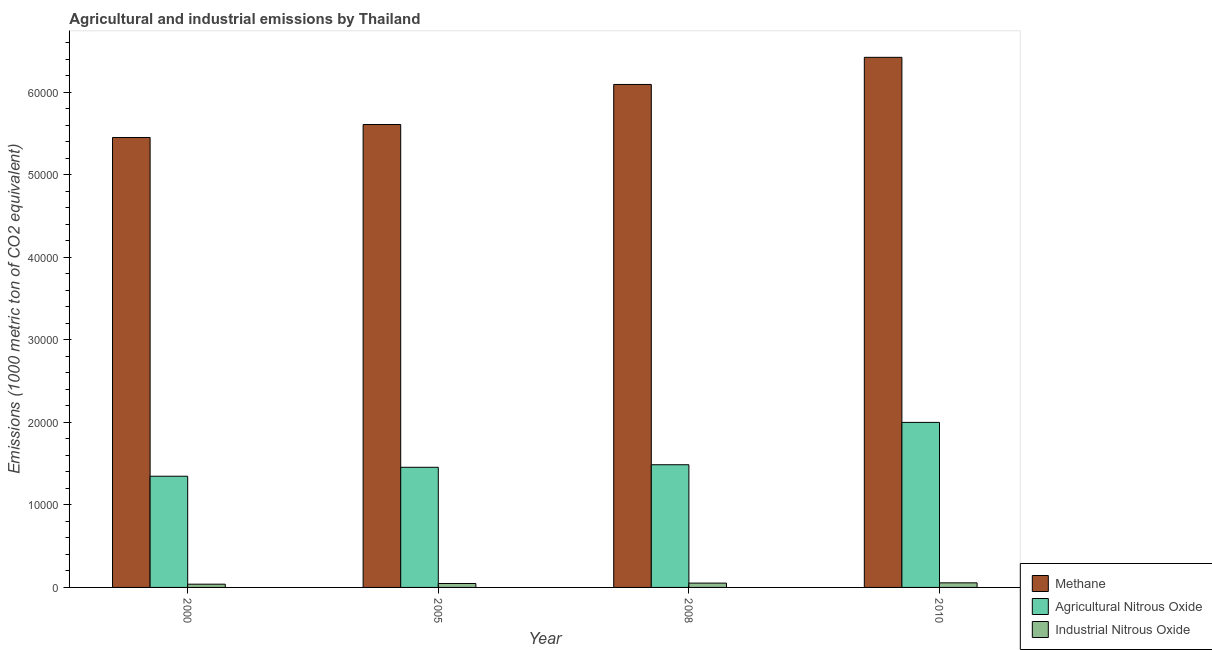Are the number of bars per tick equal to the number of legend labels?
Provide a short and direct response. Yes. Are the number of bars on each tick of the X-axis equal?
Provide a short and direct response. Yes. How many bars are there on the 2nd tick from the left?
Give a very brief answer. 3. In how many cases, is the number of bars for a given year not equal to the number of legend labels?
Provide a short and direct response. 0. What is the amount of industrial nitrous oxide emissions in 2005?
Make the answer very short. 477.4. Across all years, what is the maximum amount of agricultural nitrous oxide emissions?
Your answer should be compact. 2.00e+04. Across all years, what is the minimum amount of agricultural nitrous oxide emissions?
Offer a very short reply. 1.35e+04. What is the total amount of methane emissions in the graph?
Give a very brief answer. 2.36e+05. What is the difference between the amount of industrial nitrous oxide emissions in 2005 and that in 2010?
Keep it short and to the point. -77.2. What is the difference between the amount of methane emissions in 2008 and the amount of agricultural nitrous oxide emissions in 2005?
Offer a very short reply. 4853.3. What is the average amount of methane emissions per year?
Offer a very short reply. 5.90e+04. In the year 2005, what is the difference between the amount of industrial nitrous oxide emissions and amount of methane emissions?
Keep it short and to the point. 0. In how many years, is the amount of methane emissions greater than 36000 metric ton?
Ensure brevity in your answer.  4. What is the ratio of the amount of agricultural nitrous oxide emissions in 2005 to that in 2010?
Offer a terse response. 0.73. Is the amount of industrial nitrous oxide emissions in 2005 less than that in 2008?
Provide a succinct answer. Yes. What is the difference between the highest and the second highest amount of methane emissions?
Your response must be concise. 3287.7. What is the difference between the highest and the lowest amount of industrial nitrous oxide emissions?
Offer a very short reply. 161.2. In how many years, is the amount of agricultural nitrous oxide emissions greater than the average amount of agricultural nitrous oxide emissions taken over all years?
Your answer should be compact. 1. What does the 3rd bar from the left in 2000 represents?
Ensure brevity in your answer.  Industrial Nitrous Oxide. What does the 3rd bar from the right in 2010 represents?
Keep it short and to the point. Methane. Is it the case that in every year, the sum of the amount of methane emissions and amount of agricultural nitrous oxide emissions is greater than the amount of industrial nitrous oxide emissions?
Offer a very short reply. Yes. Are all the bars in the graph horizontal?
Keep it short and to the point. No. How many years are there in the graph?
Ensure brevity in your answer.  4. What is the difference between two consecutive major ticks on the Y-axis?
Provide a short and direct response. 10000. Are the values on the major ticks of Y-axis written in scientific E-notation?
Keep it short and to the point. No. Does the graph contain any zero values?
Keep it short and to the point. No. How many legend labels are there?
Keep it short and to the point. 3. How are the legend labels stacked?
Make the answer very short. Vertical. What is the title of the graph?
Your answer should be very brief. Agricultural and industrial emissions by Thailand. Does "Food" appear as one of the legend labels in the graph?
Your answer should be very brief. No. What is the label or title of the X-axis?
Your response must be concise. Year. What is the label or title of the Y-axis?
Provide a succinct answer. Emissions (1000 metric ton of CO2 equivalent). What is the Emissions (1000 metric ton of CO2 equivalent) of Methane in 2000?
Keep it short and to the point. 5.45e+04. What is the Emissions (1000 metric ton of CO2 equivalent) in Agricultural Nitrous Oxide in 2000?
Keep it short and to the point. 1.35e+04. What is the Emissions (1000 metric ton of CO2 equivalent) of Industrial Nitrous Oxide in 2000?
Your answer should be very brief. 393.4. What is the Emissions (1000 metric ton of CO2 equivalent) of Methane in 2005?
Offer a terse response. 5.61e+04. What is the Emissions (1000 metric ton of CO2 equivalent) in Agricultural Nitrous Oxide in 2005?
Keep it short and to the point. 1.46e+04. What is the Emissions (1000 metric ton of CO2 equivalent) in Industrial Nitrous Oxide in 2005?
Offer a very short reply. 477.4. What is the Emissions (1000 metric ton of CO2 equivalent) of Methane in 2008?
Provide a short and direct response. 6.10e+04. What is the Emissions (1000 metric ton of CO2 equivalent) of Agricultural Nitrous Oxide in 2008?
Keep it short and to the point. 1.49e+04. What is the Emissions (1000 metric ton of CO2 equivalent) of Industrial Nitrous Oxide in 2008?
Your answer should be compact. 524. What is the Emissions (1000 metric ton of CO2 equivalent) of Methane in 2010?
Offer a terse response. 6.42e+04. What is the Emissions (1000 metric ton of CO2 equivalent) in Agricultural Nitrous Oxide in 2010?
Offer a very short reply. 2.00e+04. What is the Emissions (1000 metric ton of CO2 equivalent) of Industrial Nitrous Oxide in 2010?
Your answer should be compact. 554.6. Across all years, what is the maximum Emissions (1000 metric ton of CO2 equivalent) of Methane?
Ensure brevity in your answer.  6.42e+04. Across all years, what is the maximum Emissions (1000 metric ton of CO2 equivalent) of Agricultural Nitrous Oxide?
Your response must be concise. 2.00e+04. Across all years, what is the maximum Emissions (1000 metric ton of CO2 equivalent) in Industrial Nitrous Oxide?
Your answer should be very brief. 554.6. Across all years, what is the minimum Emissions (1000 metric ton of CO2 equivalent) in Methane?
Offer a terse response. 5.45e+04. Across all years, what is the minimum Emissions (1000 metric ton of CO2 equivalent) in Agricultural Nitrous Oxide?
Provide a short and direct response. 1.35e+04. Across all years, what is the minimum Emissions (1000 metric ton of CO2 equivalent) in Industrial Nitrous Oxide?
Offer a very short reply. 393.4. What is the total Emissions (1000 metric ton of CO2 equivalent) of Methane in the graph?
Your answer should be compact. 2.36e+05. What is the total Emissions (1000 metric ton of CO2 equivalent) of Agricultural Nitrous Oxide in the graph?
Keep it short and to the point. 6.29e+04. What is the total Emissions (1000 metric ton of CO2 equivalent) of Industrial Nitrous Oxide in the graph?
Make the answer very short. 1949.4. What is the difference between the Emissions (1000 metric ton of CO2 equivalent) of Methane in 2000 and that in 2005?
Your answer should be very brief. -1573.2. What is the difference between the Emissions (1000 metric ton of CO2 equivalent) in Agricultural Nitrous Oxide in 2000 and that in 2005?
Make the answer very short. -1081.7. What is the difference between the Emissions (1000 metric ton of CO2 equivalent) of Industrial Nitrous Oxide in 2000 and that in 2005?
Keep it short and to the point. -84. What is the difference between the Emissions (1000 metric ton of CO2 equivalent) of Methane in 2000 and that in 2008?
Provide a short and direct response. -6426.5. What is the difference between the Emissions (1000 metric ton of CO2 equivalent) of Agricultural Nitrous Oxide in 2000 and that in 2008?
Ensure brevity in your answer.  -1391. What is the difference between the Emissions (1000 metric ton of CO2 equivalent) of Industrial Nitrous Oxide in 2000 and that in 2008?
Give a very brief answer. -130.6. What is the difference between the Emissions (1000 metric ton of CO2 equivalent) in Methane in 2000 and that in 2010?
Provide a short and direct response. -9714.2. What is the difference between the Emissions (1000 metric ton of CO2 equivalent) in Agricultural Nitrous Oxide in 2000 and that in 2010?
Give a very brief answer. -6523.1. What is the difference between the Emissions (1000 metric ton of CO2 equivalent) in Industrial Nitrous Oxide in 2000 and that in 2010?
Keep it short and to the point. -161.2. What is the difference between the Emissions (1000 metric ton of CO2 equivalent) of Methane in 2005 and that in 2008?
Offer a very short reply. -4853.3. What is the difference between the Emissions (1000 metric ton of CO2 equivalent) of Agricultural Nitrous Oxide in 2005 and that in 2008?
Make the answer very short. -309.3. What is the difference between the Emissions (1000 metric ton of CO2 equivalent) in Industrial Nitrous Oxide in 2005 and that in 2008?
Keep it short and to the point. -46.6. What is the difference between the Emissions (1000 metric ton of CO2 equivalent) of Methane in 2005 and that in 2010?
Make the answer very short. -8141. What is the difference between the Emissions (1000 metric ton of CO2 equivalent) of Agricultural Nitrous Oxide in 2005 and that in 2010?
Provide a succinct answer. -5441.4. What is the difference between the Emissions (1000 metric ton of CO2 equivalent) in Industrial Nitrous Oxide in 2005 and that in 2010?
Ensure brevity in your answer.  -77.2. What is the difference between the Emissions (1000 metric ton of CO2 equivalent) in Methane in 2008 and that in 2010?
Your answer should be very brief. -3287.7. What is the difference between the Emissions (1000 metric ton of CO2 equivalent) in Agricultural Nitrous Oxide in 2008 and that in 2010?
Your answer should be compact. -5132.1. What is the difference between the Emissions (1000 metric ton of CO2 equivalent) of Industrial Nitrous Oxide in 2008 and that in 2010?
Make the answer very short. -30.6. What is the difference between the Emissions (1000 metric ton of CO2 equivalent) of Methane in 2000 and the Emissions (1000 metric ton of CO2 equivalent) of Agricultural Nitrous Oxide in 2005?
Your response must be concise. 4.00e+04. What is the difference between the Emissions (1000 metric ton of CO2 equivalent) of Methane in 2000 and the Emissions (1000 metric ton of CO2 equivalent) of Industrial Nitrous Oxide in 2005?
Offer a terse response. 5.40e+04. What is the difference between the Emissions (1000 metric ton of CO2 equivalent) of Agricultural Nitrous Oxide in 2000 and the Emissions (1000 metric ton of CO2 equivalent) of Industrial Nitrous Oxide in 2005?
Provide a succinct answer. 1.30e+04. What is the difference between the Emissions (1000 metric ton of CO2 equivalent) of Methane in 2000 and the Emissions (1000 metric ton of CO2 equivalent) of Agricultural Nitrous Oxide in 2008?
Offer a very short reply. 3.97e+04. What is the difference between the Emissions (1000 metric ton of CO2 equivalent) of Methane in 2000 and the Emissions (1000 metric ton of CO2 equivalent) of Industrial Nitrous Oxide in 2008?
Your response must be concise. 5.40e+04. What is the difference between the Emissions (1000 metric ton of CO2 equivalent) in Agricultural Nitrous Oxide in 2000 and the Emissions (1000 metric ton of CO2 equivalent) in Industrial Nitrous Oxide in 2008?
Give a very brief answer. 1.30e+04. What is the difference between the Emissions (1000 metric ton of CO2 equivalent) of Methane in 2000 and the Emissions (1000 metric ton of CO2 equivalent) of Agricultural Nitrous Oxide in 2010?
Your response must be concise. 3.45e+04. What is the difference between the Emissions (1000 metric ton of CO2 equivalent) of Methane in 2000 and the Emissions (1000 metric ton of CO2 equivalent) of Industrial Nitrous Oxide in 2010?
Your answer should be compact. 5.40e+04. What is the difference between the Emissions (1000 metric ton of CO2 equivalent) in Agricultural Nitrous Oxide in 2000 and the Emissions (1000 metric ton of CO2 equivalent) in Industrial Nitrous Oxide in 2010?
Provide a short and direct response. 1.29e+04. What is the difference between the Emissions (1000 metric ton of CO2 equivalent) of Methane in 2005 and the Emissions (1000 metric ton of CO2 equivalent) of Agricultural Nitrous Oxide in 2008?
Give a very brief answer. 4.12e+04. What is the difference between the Emissions (1000 metric ton of CO2 equivalent) of Methane in 2005 and the Emissions (1000 metric ton of CO2 equivalent) of Industrial Nitrous Oxide in 2008?
Give a very brief answer. 5.56e+04. What is the difference between the Emissions (1000 metric ton of CO2 equivalent) in Agricultural Nitrous Oxide in 2005 and the Emissions (1000 metric ton of CO2 equivalent) in Industrial Nitrous Oxide in 2008?
Ensure brevity in your answer.  1.40e+04. What is the difference between the Emissions (1000 metric ton of CO2 equivalent) of Methane in 2005 and the Emissions (1000 metric ton of CO2 equivalent) of Agricultural Nitrous Oxide in 2010?
Ensure brevity in your answer.  3.61e+04. What is the difference between the Emissions (1000 metric ton of CO2 equivalent) of Methane in 2005 and the Emissions (1000 metric ton of CO2 equivalent) of Industrial Nitrous Oxide in 2010?
Give a very brief answer. 5.55e+04. What is the difference between the Emissions (1000 metric ton of CO2 equivalent) of Agricultural Nitrous Oxide in 2005 and the Emissions (1000 metric ton of CO2 equivalent) of Industrial Nitrous Oxide in 2010?
Offer a terse response. 1.40e+04. What is the difference between the Emissions (1000 metric ton of CO2 equivalent) in Methane in 2008 and the Emissions (1000 metric ton of CO2 equivalent) in Agricultural Nitrous Oxide in 2010?
Keep it short and to the point. 4.10e+04. What is the difference between the Emissions (1000 metric ton of CO2 equivalent) in Methane in 2008 and the Emissions (1000 metric ton of CO2 equivalent) in Industrial Nitrous Oxide in 2010?
Keep it short and to the point. 6.04e+04. What is the difference between the Emissions (1000 metric ton of CO2 equivalent) of Agricultural Nitrous Oxide in 2008 and the Emissions (1000 metric ton of CO2 equivalent) of Industrial Nitrous Oxide in 2010?
Give a very brief answer. 1.43e+04. What is the average Emissions (1000 metric ton of CO2 equivalent) in Methane per year?
Your answer should be very brief. 5.90e+04. What is the average Emissions (1000 metric ton of CO2 equivalent) in Agricultural Nitrous Oxide per year?
Your answer should be very brief. 1.57e+04. What is the average Emissions (1000 metric ton of CO2 equivalent) in Industrial Nitrous Oxide per year?
Your response must be concise. 487.35. In the year 2000, what is the difference between the Emissions (1000 metric ton of CO2 equivalent) in Methane and Emissions (1000 metric ton of CO2 equivalent) in Agricultural Nitrous Oxide?
Your response must be concise. 4.10e+04. In the year 2000, what is the difference between the Emissions (1000 metric ton of CO2 equivalent) in Methane and Emissions (1000 metric ton of CO2 equivalent) in Industrial Nitrous Oxide?
Make the answer very short. 5.41e+04. In the year 2000, what is the difference between the Emissions (1000 metric ton of CO2 equivalent) of Agricultural Nitrous Oxide and Emissions (1000 metric ton of CO2 equivalent) of Industrial Nitrous Oxide?
Make the answer very short. 1.31e+04. In the year 2005, what is the difference between the Emissions (1000 metric ton of CO2 equivalent) of Methane and Emissions (1000 metric ton of CO2 equivalent) of Agricultural Nitrous Oxide?
Your response must be concise. 4.15e+04. In the year 2005, what is the difference between the Emissions (1000 metric ton of CO2 equivalent) in Methane and Emissions (1000 metric ton of CO2 equivalent) in Industrial Nitrous Oxide?
Offer a terse response. 5.56e+04. In the year 2005, what is the difference between the Emissions (1000 metric ton of CO2 equivalent) of Agricultural Nitrous Oxide and Emissions (1000 metric ton of CO2 equivalent) of Industrial Nitrous Oxide?
Your response must be concise. 1.41e+04. In the year 2008, what is the difference between the Emissions (1000 metric ton of CO2 equivalent) of Methane and Emissions (1000 metric ton of CO2 equivalent) of Agricultural Nitrous Oxide?
Keep it short and to the point. 4.61e+04. In the year 2008, what is the difference between the Emissions (1000 metric ton of CO2 equivalent) of Methane and Emissions (1000 metric ton of CO2 equivalent) of Industrial Nitrous Oxide?
Make the answer very short. 6.04e+04. In the year 2008, what is the difference between the Emissions (1000 metric ton of CO2 equivalent) in Agricultural Nitrous Oxide and Emissions (1000 metric ton of CO2 equivalent) in Industrial Nitrous Oxide?
Offer a terse response. 1.43e+04. In the year 2010, what is the difference between the Emissions (1000 metric ton of CO2 equivalent) of Methane and Emissions (1000 metric ton of CO2 equivalent) of Agricultural Nitrous Oxide?
Your response must be concise. 4.42e+04. In the year 2010, what is the difference between the Emissions (1000 metric ton of CO2 equivalent) in Methane and Emissions (1000 metric ton of CO2 equivalent) in Industrial Nitrous Oxide?
Your response must be concise. 6.37e+04. In the year 2010, what is the difference between the Emissions (1000 metric ton of CO2 equivalent) of Agricultural Nitrous Oxide and Emissions (1000 metric ton of CO2 equivalent) of Industrial Nitrous Oxide?
Your answer should be very brief. 1.94e+04. What is the ratio of the Emissions (1000 metric ton of CO2 equivalent) of Agricultural Nitrous Oxide in 2000 to that in 2005?
Your answer should be very brief. 0.93. What is the ratio of the Emissions (1000 metric ton of CO2 equivalent) of Industrial Nitrous Oxide in 2000 to that in 2005?
Ensure brevity in your answer.  0.82. What is the ratio of the Emissions (1000 metric ton of CO2 equivalent) of Methane in 2000 to that in 2008?
Ensure brevity in your answer.  0.89. What is the ratio of the Emissions (1000 metric ton of CO2 equivalent) of Agricultural Nitrous Oxide in 2000 to that in 2008?
Your answer should be very brief. 0.91. What is the ratio of the Emissions (1000 metric ton of CO2 equivalent) of Industrial Nitrous Oxide in 2000 to that in 2008?
Offer a very short reply. 0.75. What is the ratio of the Emissions (1000 metric ton of CO2 equivalent) of Methane in 2000 to that in 2010?
Offer a very short reply. 0.85. What is the ratio of the Emissions (1000 metric ton of CO2 equivalent) of Agricultural Nitrous Oxide in 2000 to that in 2010?
Offer a very short reply. 0.67. What is the ratio of the Emissions (1000 metric ton of CO2 equivalent) in Industrial Nitrous Oxide in 2000 to that in 2010?
Give a very brief answer. 0.71. What is the ratio of the Emissions (1000 metric ton of CO2 equivalent) in Methane in 2005 to that in 2008?
Your response must be concise. 0.92. What is the ratio of the Emissions (1000 metric ton of CO2 equivalent) of Agricultural Nitrous Oxide in 2005 to that in 2008?
Your answer should be compact. 0.98. What is the ratio of the Emissions (1000 metric ton of CO2 equivalent) of Industrial Nitrous Oxide in 2005 to that in 2008?
Your answer should be compact. 0.91. What is the ratio of the Emissions (1000 metric ton of CO2 equivalent) in Methane in 2005 to that in 2010?
Ensure brevity in your answer.  0.87. What is the ratio of the Emissions (1000 metric ton of CO2 equivalent) of Agricultural Nitrous Oxide in 2005 to that in 2010?
Your response must be concise. 0.73. What is the ratio of the Emissions (1000 metric ton of CO2 equivalent) of Industrial Nitrous Oxide in 2005 to that in 2010?
Provide a succinct answer. 0.86. What is the ratio of the Emissions (1000 metric ton of CO2 equivalent) of Methane in 2008 to that in 2010?
Keep it short and to the point. 0.95. What is the ratio of the Emissions (1000 metric ton of CO2 equivalent) in Agricultural Nitrous Oxide in 2008 to that in 2010?
Your response must be concise. 0.74. What is the ratio of the Emissions (1000 metric ton of CO2 equivalent) of Industrial Nitrous Oxide in 2008 to that in 2010?
Your answer should be compact. 0.94. What is the difference between the highest and the second highest Emissions (1000 metric ton of CO2 equivalent) in Methane?
Your response must be concise. 3287.7. What is the difference between the highest and the second highest Emissions (1000 metric ton of CO2 equivalent) of Agricultural Nitrous Oxide?
Your answer should be compact. 5132.1. What is the difference between the highest and the second highest Emissions (1000 metric ton of CO2 equivalent) in Industrial Nitrous Oxide?
Keep it short and to the point. 30.6. What is the difference between the highest and the lowest Emissions (1000 metric ton of CO2 equivalent) in Methane?
Provide a succinct answer. 9714.2. What is the difference between the highest and the lowest Emissions (1000 metric ton of CO2 equivalent) of Agricultural Nitrous Oxide?
Ensure brevity in your answer.  6523.1. What is the difference between the highest and the lowest Emissions (1000 metric ton of CO2 equivalent) in Industrial Nitrous Oxide?
Your response must be concise. 161.2. 